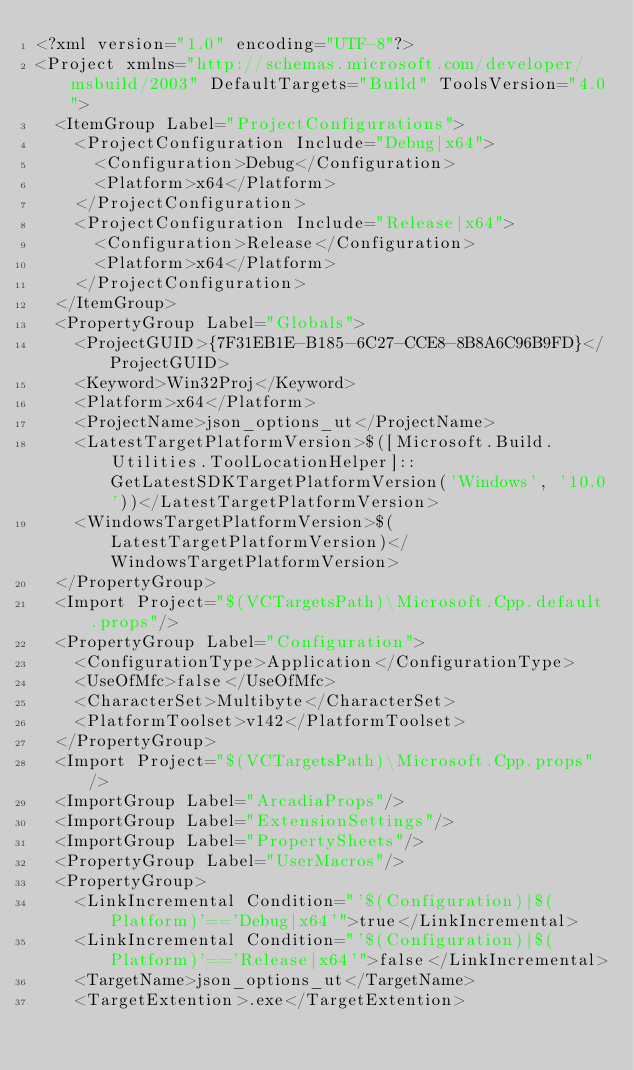<code> <loc_0><loc_0><loc_500><loc_500><_XML_><?xml version="1.0" encoding="UTF-8"?>
<Project xmlns="http://schemas.microsoft.com/developer/msbuild/2003" DefaultTargets="Build" ToolsVersion="4.0">
  <ItemGroup Label="ProjectConfigurations">
    <ProjectConfiguration Include="Debug|x64">
      <Configuration>Debug</Configuration>
      <Platform>x64</Platform>
    </ProjectConfiguration>
    <ProjectConfiguration Include="Release|x64">
      <Configuration>Release</Configuration>
      <Platform>x64</Platform>
    </ProjectConfiguration>
  </ItemGroup>
  <PropertyGroup Label="Globals">
    <ProjectGUID>{7F31EB1E-B185-6C27-CCE8-8B8A6C96B9FD}</ProjectGUID>
    <Keyword>Win32Proj</Keyword>
    <Platform>x64</Platform>
    <ProjectName>json_options_ut</ProjectName>
    <LatestTargetPlatformVersion>$([Microsoft.Build.Utilities.ToolLocationHelper]::GetLatestSDKTargetPlatformVersion('Windows', '10.0'))</LatestTargetPlatformVersion>
    <WindowsTargetPlatformVersion>$(LatestTargetPlatformVersion)</WindowsTargetPlatformVersion>
  </PropertyGroup>
  <Import Project="$(VCTargetsPath)\Microsoft.Cpp.default.props"/>
  <PropertyGroup Label="Configuration">
    <ConfigurationType>Application</ConfigurationType>
    <UseOfMfc>false</UseOfMfc>
    <CharacterSet>Multibyte</CharacterSet>
    <PlatformToolset>v142</PlatformToolset>
  </PropertyGroup>
  <Import Project="$(VCTargetsPath)\Microsoft.Cpp.props"/>
  <ImportGroup Label="ArcadiaProps"/>
  <ImportGroup Label="ExtensionSettings"/>
  <ImportGroup Label="PropertySheets"/>
  <PropertyGroup Label="UserMacros"/>
  <PropertyGroup>
    <LinkIncremental Condition="'$(Configuration)|$(Platform)'=='Debug|x64'">true</LinkIncremental>
    <LinkIncremental Condition="'$(Configuration)|$(Platform)'=='Release|x64'">false</LinkIncremental>
    <TargetName>json_options_ut</TargetName>
    <TargetExtention>.exe</TargetExtention></code> 